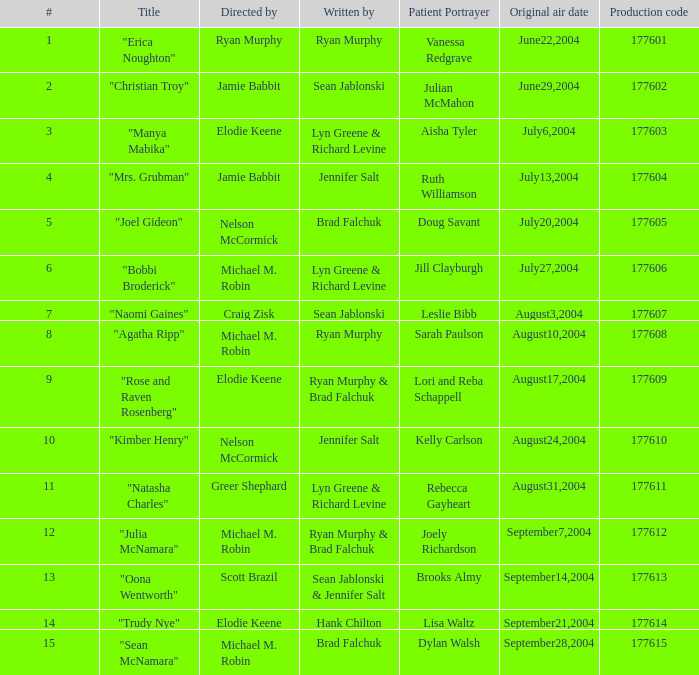What is the maximum numbered episode with patient portrayal artist doug savant? 5.0. 